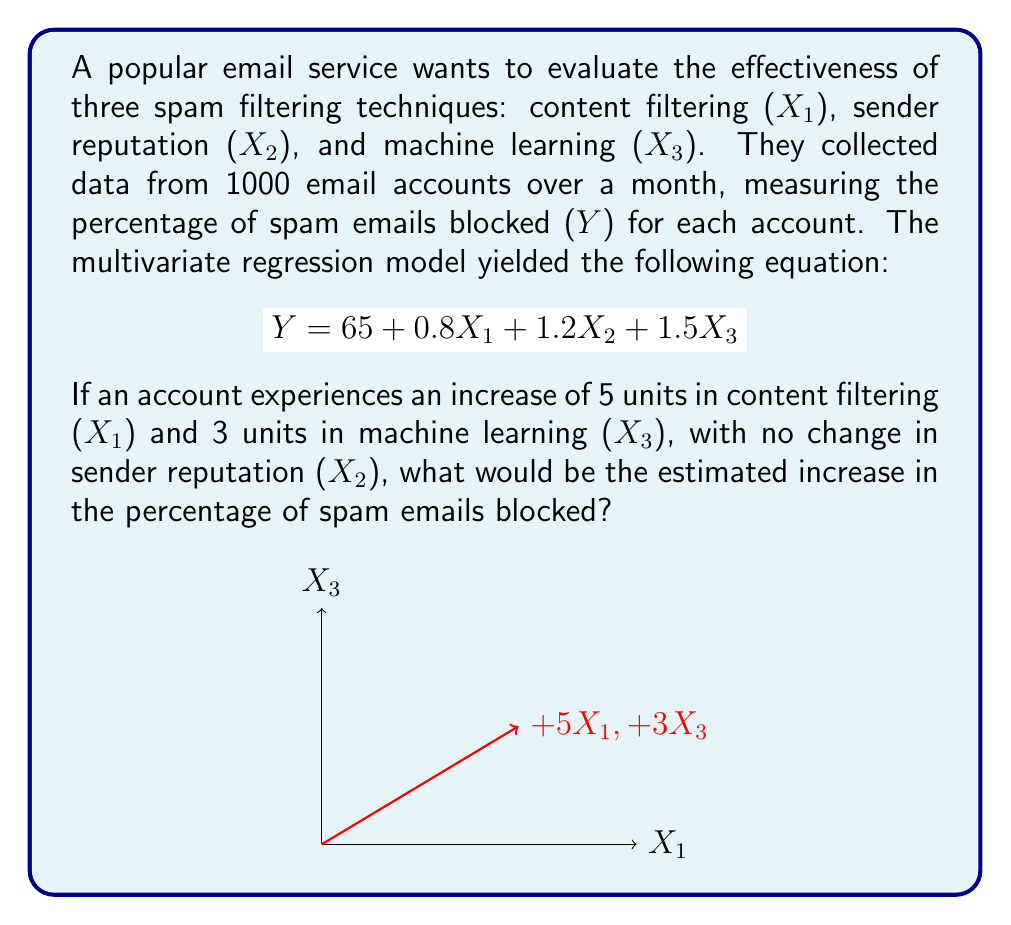What is the answer to this math problem? To solve this problem, we'll follow these steps:

1. Understand the given multivariate regression equation:
   $$Y = 65 + 0.8X_1 + 1.2X_2 + 1.5X_3$$
   Where Y is the percentage of spam emails blocked, and X₁, X₂, and X₃ represent the three filtering techniques.

2. Identify the changes in each variable:
   - X₁ (content filtering) increases by 5 units
   - X₂ (sender reputation) has no change (0 units)
   - X₃ (machine learning) increases by 3 units

3. Calculate the effect of each change:
   - Effect of X₁: $0.8 \times 5 = 4$
   - Effect of X₂: $1.2 \times 0 = 0$
   - Effect of X₃: $1.5 \times 3 = 4.5$

4. Sum up the total effect:
   Total increase = Effect of X₁ + Effect of X₂ + Effect of X₃
   $$ 4 + 0 + 4.5 = 8.5 $$

Therefore, the estimated increase in the percentage of spam emails blocked would be 8.5%.
Answer: 8.5% 